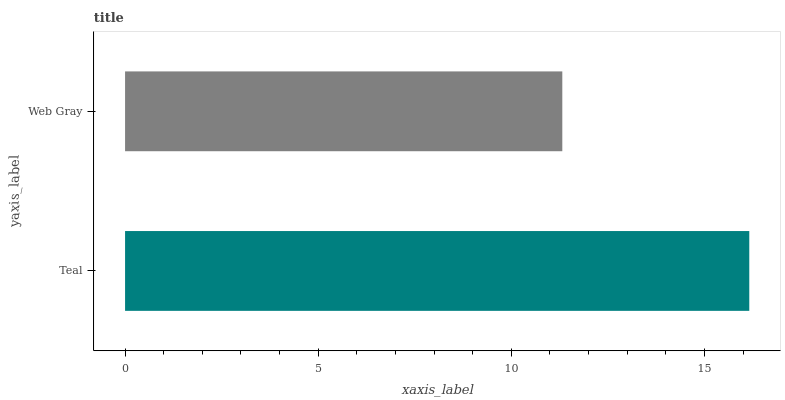Is Web Gray the minimum?
Answer yes or no. Yes. Is Teal the maximum?
Answer yes or no. Yes. Is Web Gray the maximum?
Answer yes or no. No. Is Teal greater than Web Gray?
Answer yes or no. Yes. Is Web Gray less than Teal?
Answer yes or no. Yes. Is Web Gray greater than Teal?
Answer yes or no. No. Is Teal less than Web Gray?
Answer yes or no. No. Is Teal the high median?
Answer yes or no. Yes. Is Web Gray the low median?
Answer yes or no. Yes. Is Web Gray the high median?
Answer yes or no. No. Is Teal the low median?
Answer yes or no. No. 